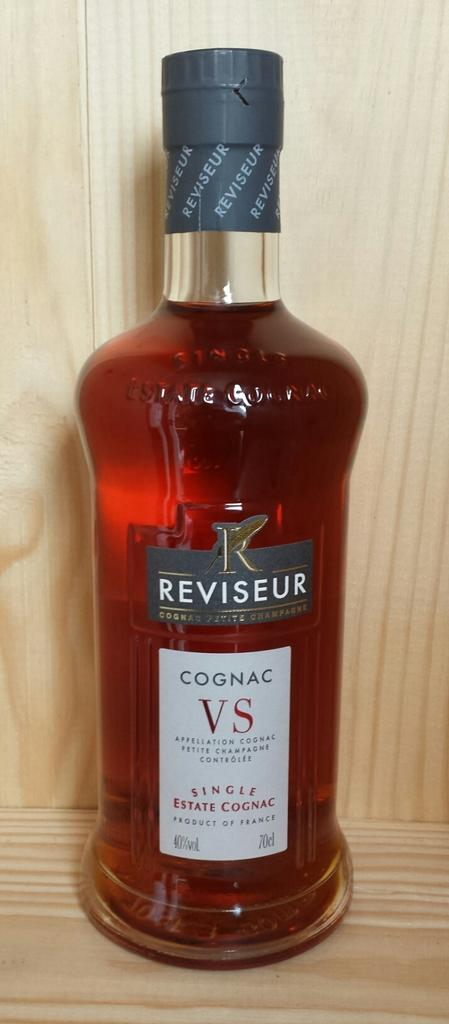What is the main object in the image? There is a wine bottle in the image. Where is the wine bottle located? The wine bottle is in a rack. What additional feature is present on the wine bottle? There is a sticker on the wine bottle. What does the sticker say? The sticker has the text 'Cognac VS' on it. What type of game is being played in the image? There is no game being played in the image; it features a wine bottle in a rack with a sticker on it. What design elements are present in the image? The image does not focus on design elements; it primarily showcases a wine bottle with a sticker. 